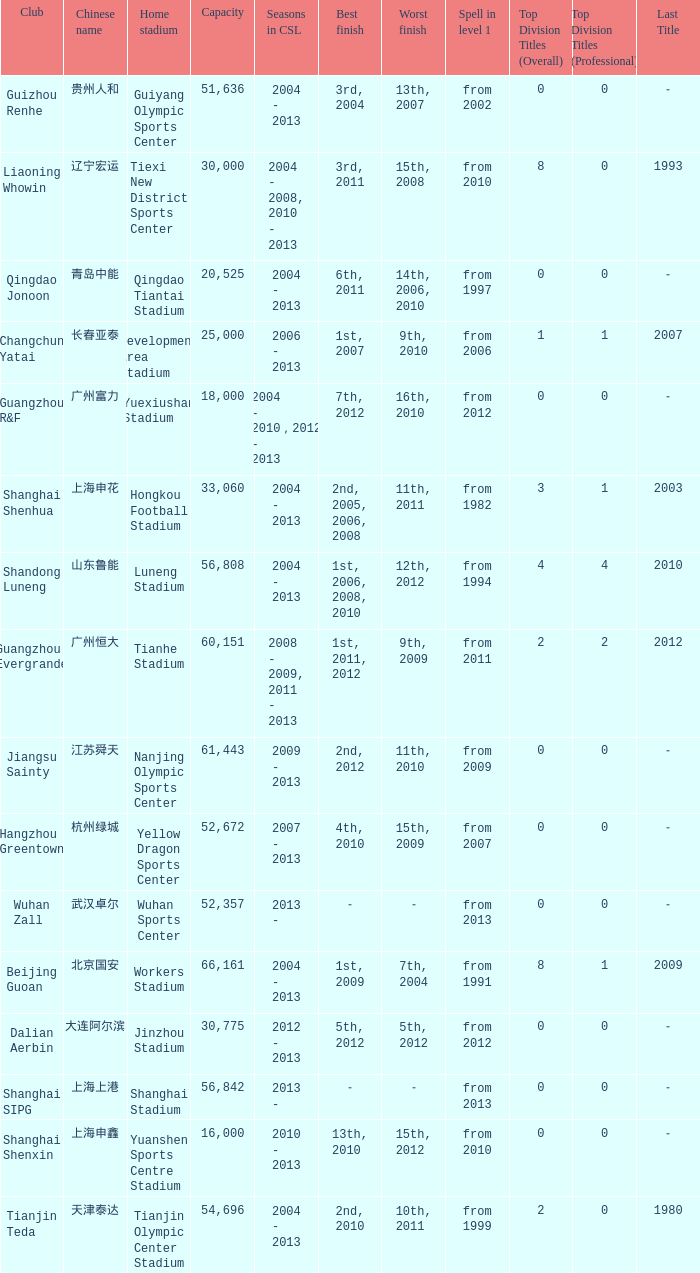What were the years for Seasons in CSL when they played in the Guiyang Olympic Sports Center and had Top Division Titles (Overall) of 0? 2004 - 2013. 